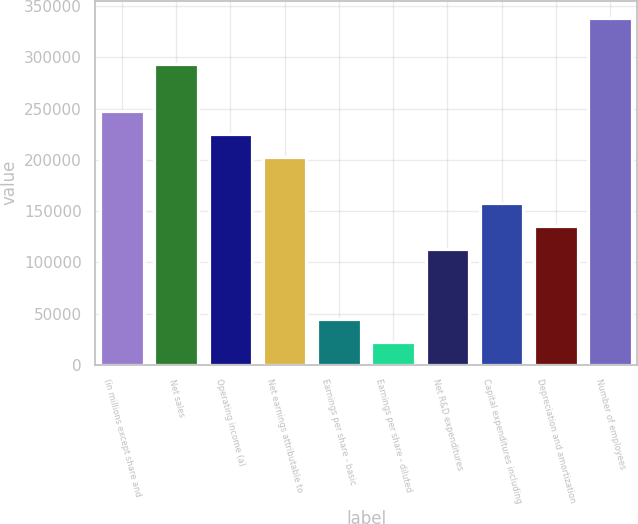Convert chart to OTSL. <chart><loc_0><loc_0><loc_500><loc_500><bar_chart><fcel>(in millions except share and<fcel>Net sales<fcel>Operating income (a)<fcel>Net earnings attributable to<fcel>Earnings per share - basic<fcel>Earnings per share - diluted<fcel>Net R&D expenditures<fcel>Capital expenditures including<fcel>Depreciation and amortization<fcel>Number of employees<nl><fcel>248213<fcel>293342<fcel>225648<fcel>203083<fcel>45130<fcel>22565.3<fcel>112824<fcel>157954<fcel>135389<fcel>338472<nl></chart> 